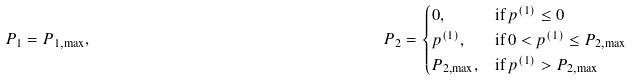Convert formula to latex. <formula><loc_0><loc_0><loc_500><loc_500>P _ { 1 } & = P _ { 1 , \max } , & \, P _ { 2 } & = \begin{cases} 0 , & \text {if} \, p ^ { ( 1 ) } \leq 0 \\ p ^ { ( 1 ) } , & \text {if} \, 0 < p ^ { ( 1 ) } \leq P _ { 2 , \max } \\ P _ { 2 , \max } , & \text {if} \, p ^ { ( 1 ) } > P _ { 2 , \max } \end{cases}</formula> 